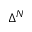<formula> <loc_0><loc_0><loc_500><loc_500>\Delta ^ { N }</formula> 